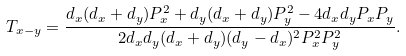Convert formula to latex. <formula><loc_0><loc_0><loc_500><loc_500>T _ { x - y } & = \frac { d _ { x } ( d _ { x } + d _ { y } ) P _ { x } ^ { 2 } + d _ { y } ( d _ { x } + d _ { y } ) P _ { y } ^ { 2 } - 4 d _ { x } d _ { y } P _ { x } P _ { y } } { 2 d _ { x } d _ { y } ( d _ { x } + d _ { y } ) ( d _ { y } - d _ { x } ) ^ { 2 } P _ { x } ^ { 2 } P _ { y } ^ { 2 } } .</formula> 